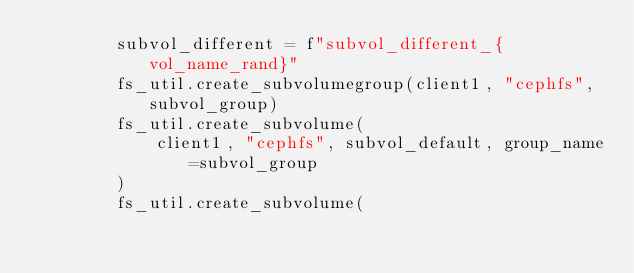Convert code to text. <code><loc_0><loc_0><loc_500><loc_500><_Python_>        subvol_different = f"subvol_different_{vol_name_rand}"
        fs_util.create_subvolumegroup(client1, "cephfs", subvol_group)
        fs_util.create_subvolume(
            client1, "cephfs", subvol_default, group_name=subvol_group
        )
        fs_util.create_subvolume(</code> 